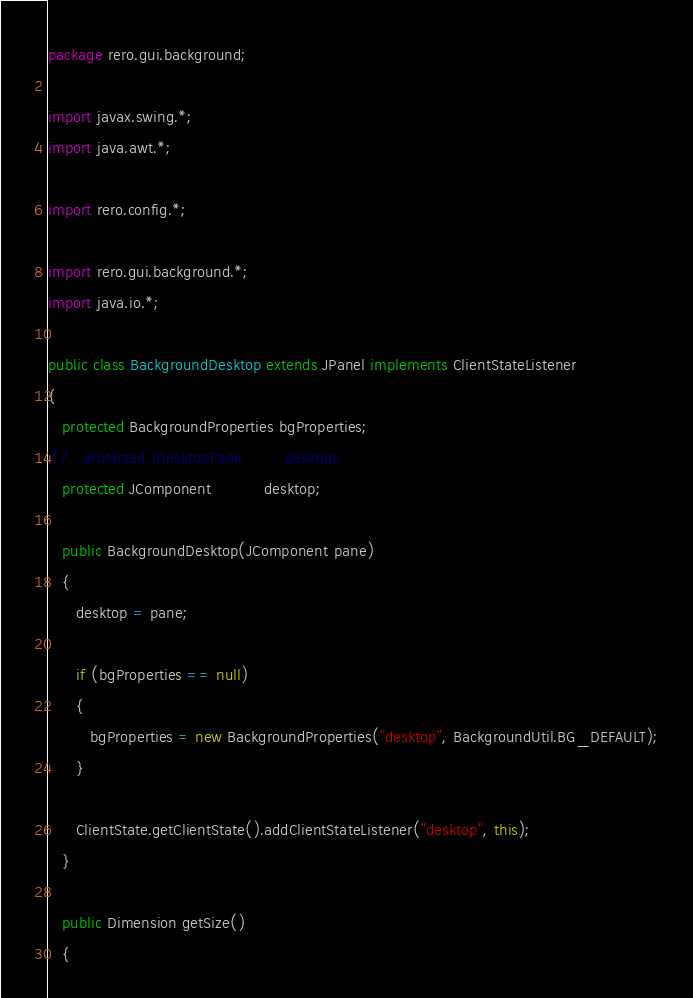Convert code to text. <code><loc_0><loc_0><loc_500><loc_500><_Java_>package rero.gui.background;

import javax.swing.*;
import java.awt.*;

import rero.config.*;

import rero.gui.background.*;
import java.io.*;

public class BackgroundDesktop extends JPanel implements ClientStateListener
{
   protected BackgroundProperties bgProperties;
//   protected JDesktopPane         desktop;
   protected JComponent           desktop;

   public BackgroundDesktop(JComponent pane)
   {
      desktop = pane;

      if (bgProperties == null)
      {
         bgProperties = new BackgroundProperties("desktop", BackgroundUtil.BG_DEFAULT);
      }

      ClientState.getClientState().addClientStateListener("desktop", this);
   }

   public Dimension getSize()
   {</code> 